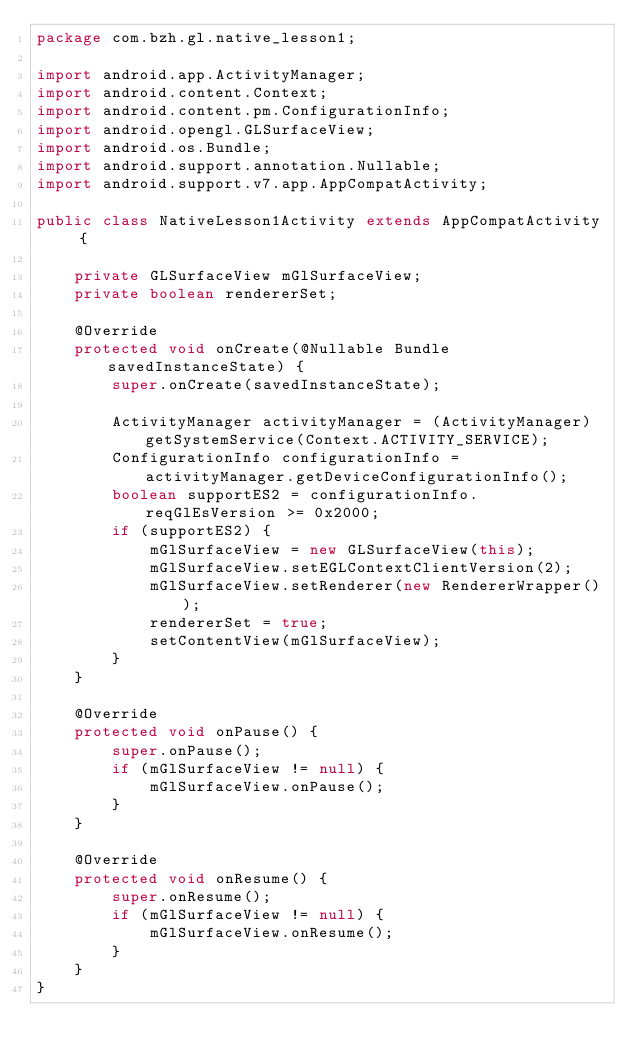Convert code to text. <code><loc_0><loc_0><loc_500><loc_500><_Java_>package com.bzh.gl.native_lesson1;

import android.app.ActivityManager;
import android.content.Context;
import android.content.pm.ConfigurationInfo;
import android.opengl.GLSurfaceView;
import android.os.Bundle;
import android.support.annotation.Nullable;
import android.support.v7.app.AppCompatActivity;

public class NativeLesson1Activity extends AppCompatActivity {

    private GLSurfaceView mGlSurfaceView;
    private boolean rendererSet;

    @Override
    protected void onCreate(@Nullable Bundle savedInstanceState) {
        super.onCreate(savedInstanceState);

        ActivityManager activityManager = (ActivityManager) getSystemService(Context.ACTIVITY_SERVICE);
        ConfigurationInfo configurationInfo = activityManager.getDeviceConfigurationInfo();
        boolean supportES2 = configurationInfo.reqGlEsVersion >= 0x2000;
        if (supportES2) {
            mGlSurfaceView = new GLSurfaceView(this);
            mGlSurfaceView.setEGLContextClientVersion(2);
            mGlSurfaceView.setRenderer(new RendererWrapper());
            rendererSet = true;
            setContentView(mGlSurfaceView);
        }
    }

    @Override
    protected void onPause() {
        super.onPause();
        if (mGlSurfaceView != null) {
            mGlSurfaceView.onPause();
        }
    }

    @Override
    protected void onResume() {
        super.onResume();
        if (mGlSurfaceView != null) {
            mGlSurfaceView.onResume();
        }
    }
}
</code> 